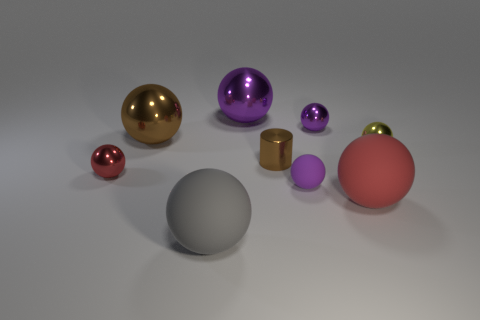Is the color of the rubber sphere that is behind the big red thing the same as the big ball that is behind the big brown shiny thing?
Ensure brevity in your answer.  Yes. There is a big ball to the right of the small purple sphere that is behind the large brown thing; what is its material?
Ensure brevity in your answer.  Rubber. Do the tiny shiny object on the left side of the large gray rubber ball and the small matte thing have the same color?
Give a very brief answer. No. Are there any other things that are the same material as the tiny brown thing?
Offer a very short reply. Yes. How many large purple matte objects are the same shape as the big brown thing?
Make the answer very short. 0. There is a yellow thing that is made of the same material as the small red ball; what is its size?
Keep it short and to the point. Small. There is a brown thing that is right of the big gray matte object left of the small brown metallic cylinder; is there a tiny yellow thing in front of it?
Your answer should be compact. No. Does the matte ball that is left of the metallic cylinder have the same size as the brown ball?
Your answer should be very brief. Yes. How many gray balls have the same size as the gray matte object?
Give a very brief answer. 0. There is a thing that is the same color as the small shiny cylinder; what is its size?
Offer a very short reply. Large. 